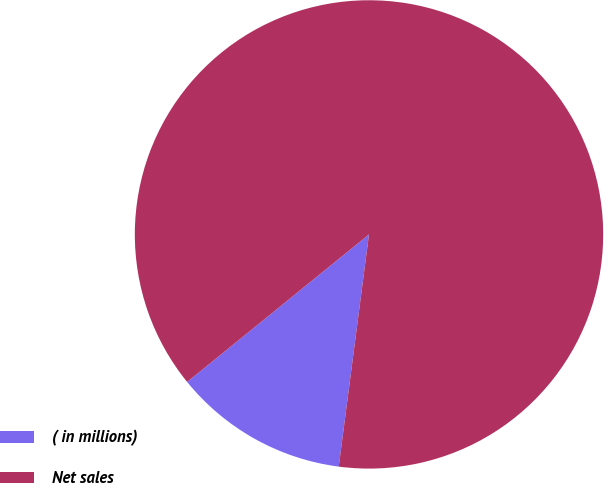Convert chart. <chart><loc_0><loc_0><loc_500><loc_500><pie_chart><fcel>( in millions)<fcel>Net sales<nl><fcel>12.09%<fcel>87.91%<nl></chart> 